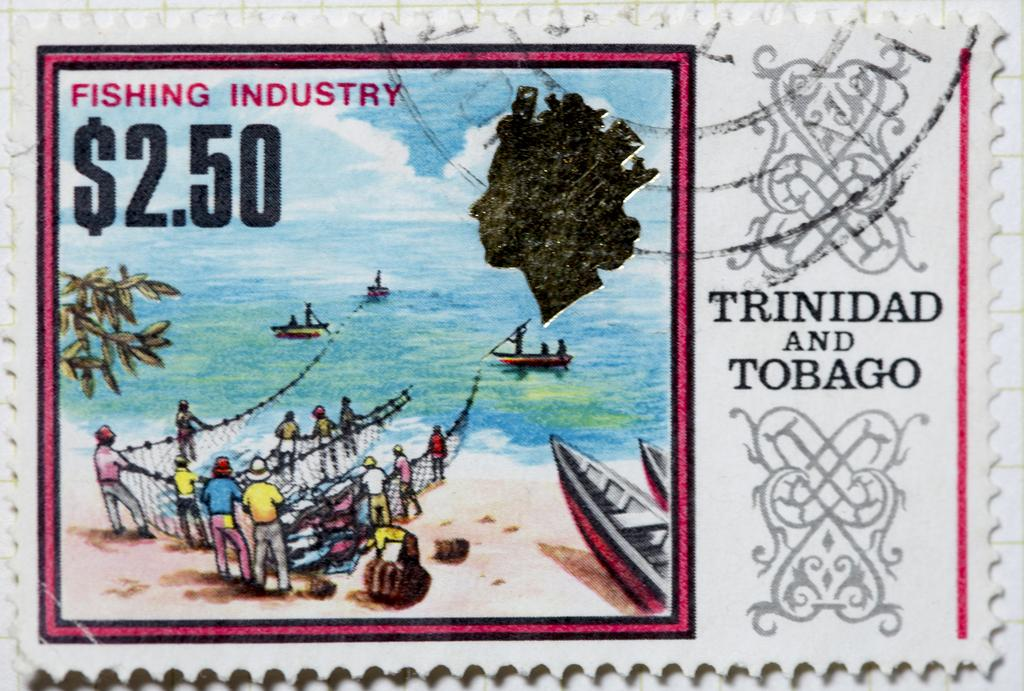What type of object is depicted in the image? The image appears to be a stamp. What is shown on the stamp? There is a poster visible on the stamp. Are there any words or letters on the stamp? Yes, there is text present on the stamp. What type of degree is being awarded in the image? There is no degree or award ceremony depicted in the image; it is a stamp featuring a poster and text. Can you tell me how many wrens are visible on the stamp? There are no wrens present in the image; it features a poster and text on a stamp. 